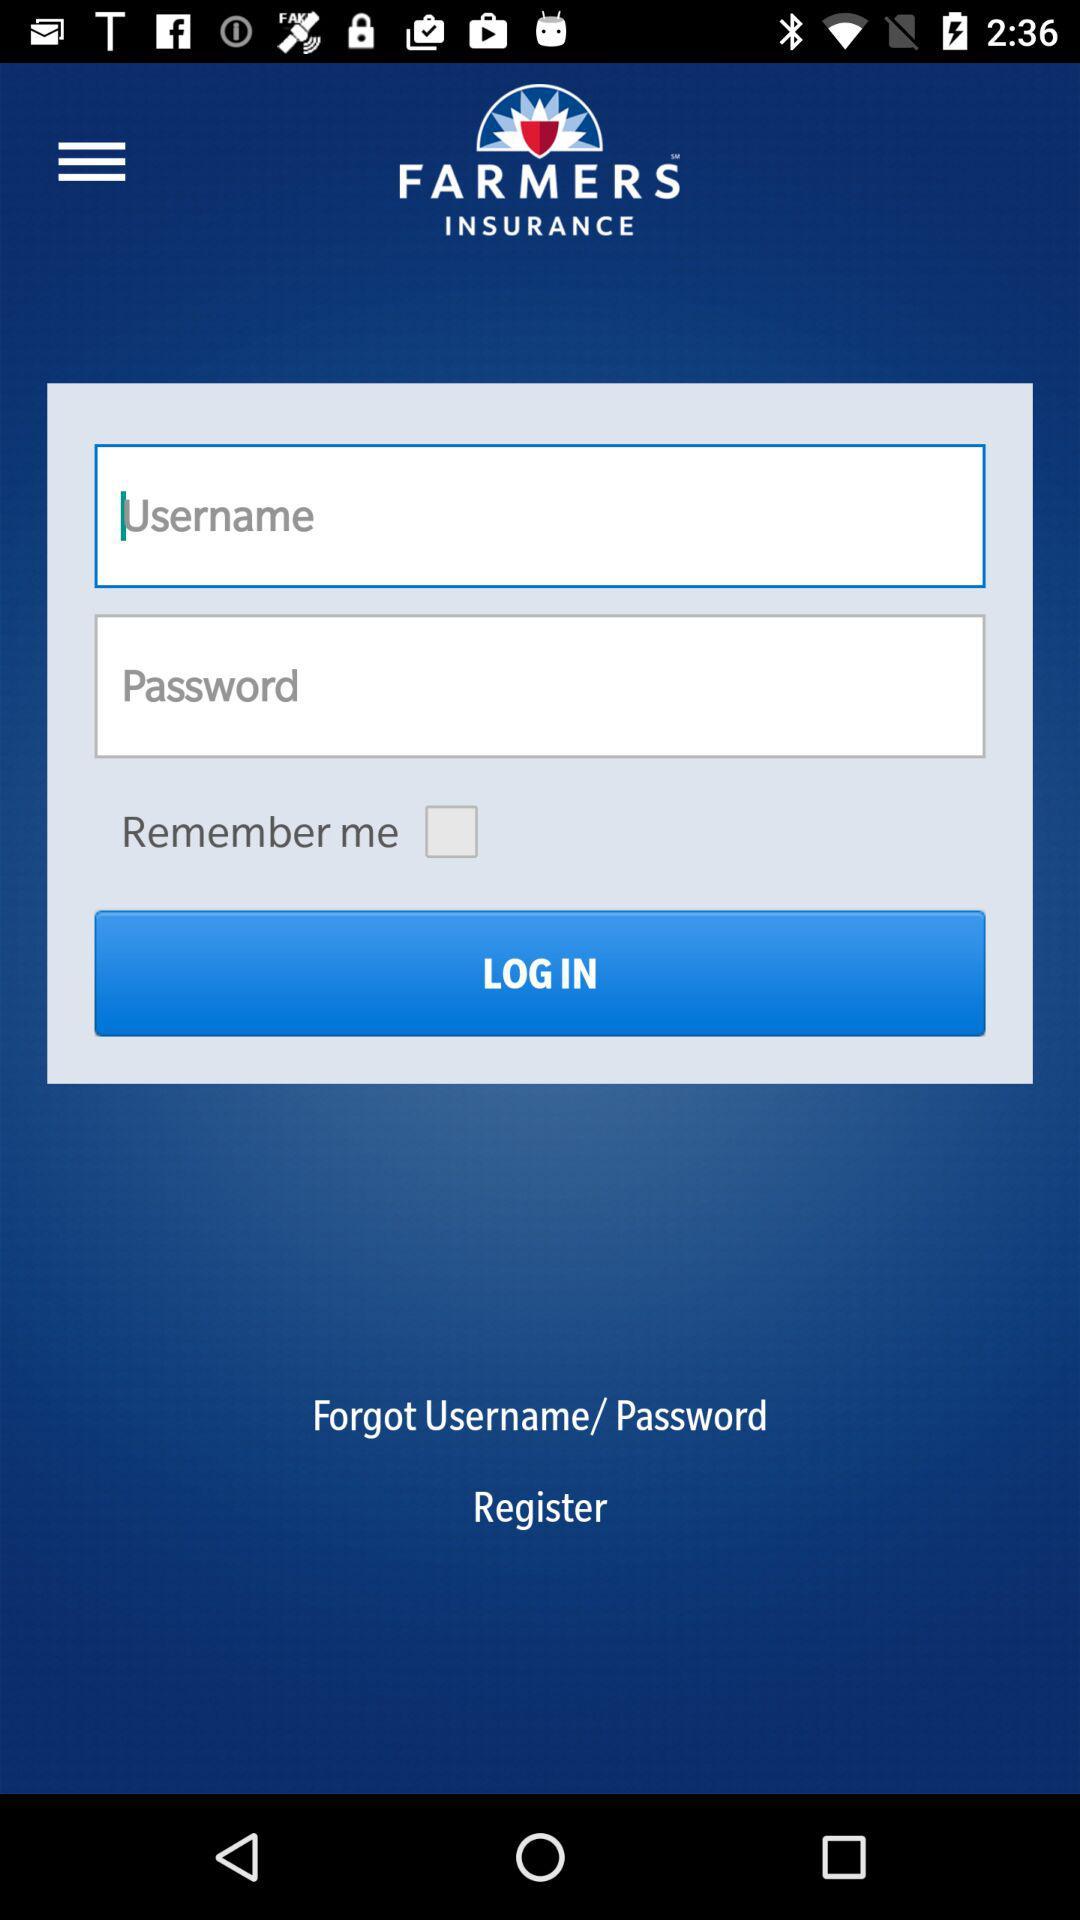What is the application name? The application name is "FARMERS INSURANCE". 